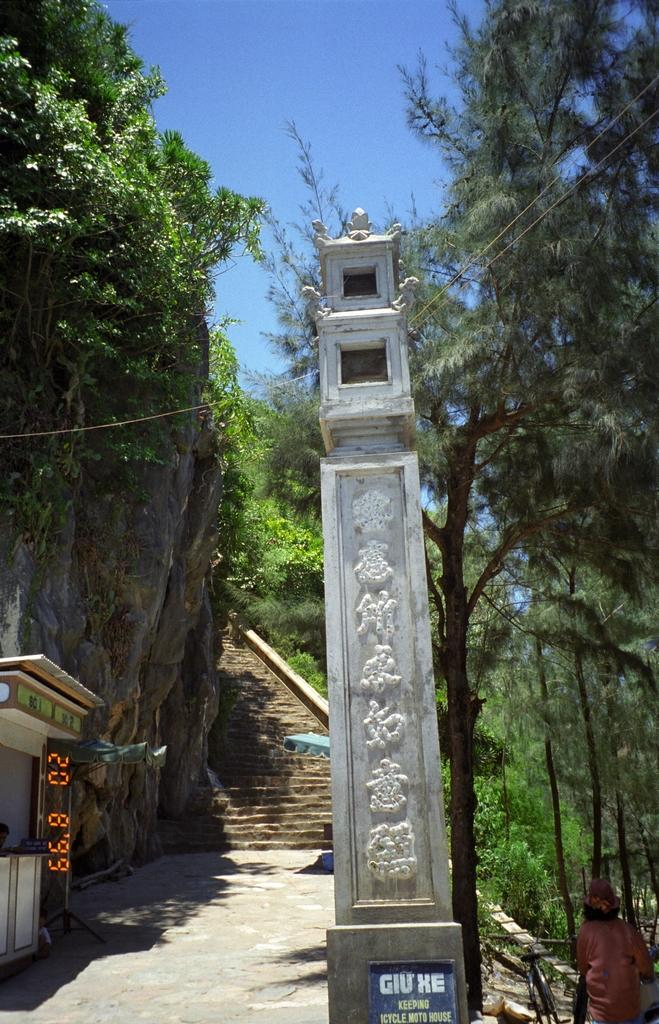What type of architectural feature is present in the image? There are stairs in the image. Where is the pillar located in the image? The pillar is on the right side of the image. What type of vegetation can be seen in the image? There are trees visible in the image. What type of screen is present on the left side of the image? There is an LCD screen on the left side of the image. Can you describe the stranger's toes in the image? There is no stranger present in the image, so it is not possible to describe their toes. 